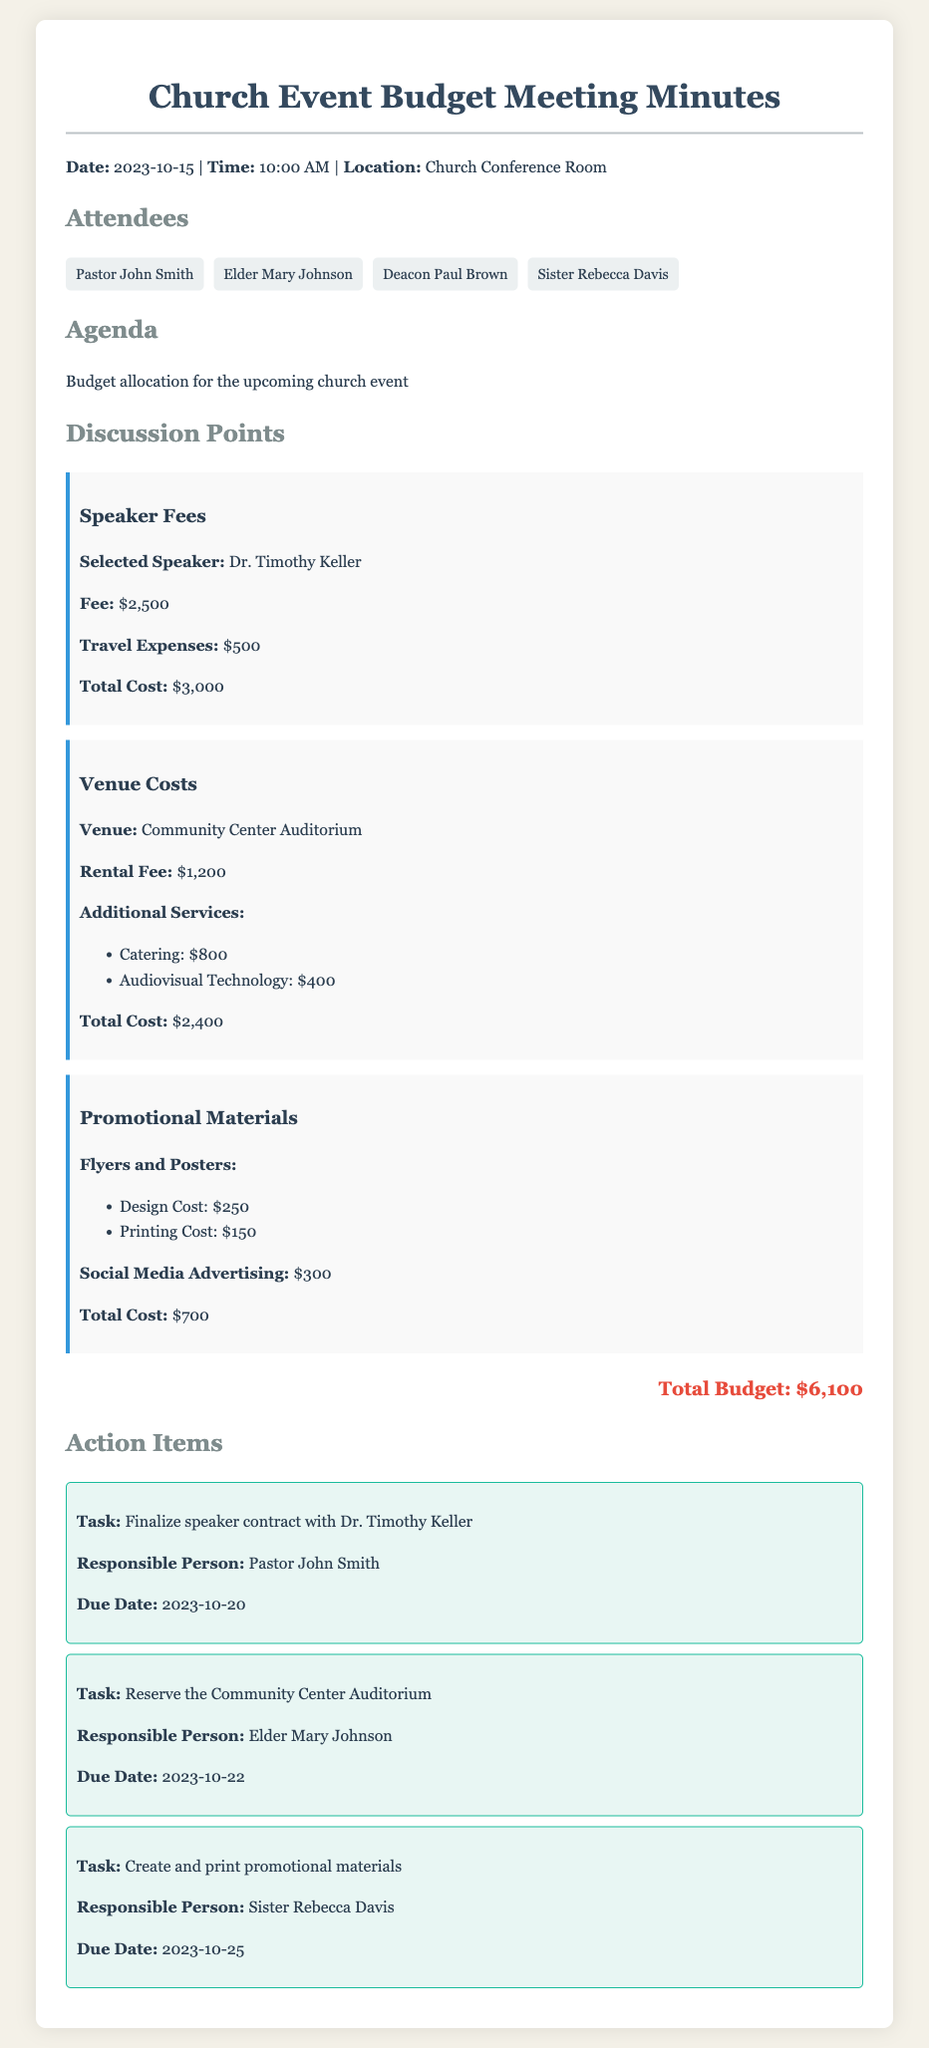What is the date of the meeting? The date of the meeting is mentioned at the beginning of the document.
Answer: 2023-10-15 Who is the selected speaker for the event? The selected speaker is listed under the discussion points section.
Answer: Dr. Timothy Keller What is the total cost for speaker fees? The total cost for speaker fees is calculated in the discussion points section.
Answer: $3,000 What is the rental fee for the venue? The rental fee is highlighted in the venue costs section.
Answer: $1,200 How much is allocated for promotional materials? The total cost for promotional materials is discussed in the corresponding section.
Answer: $700 What is the due date for finalizing the speaker contract? The due date is provided in the action items section.
Answer: 2023-10-20 How many attendees are listed in the document? The number of attendees can be counted from the attendees section.
Answer: 4 What is the total budget for the church event? The total budget is summarized at the end of the discussion points.
Answer: $6,100 Who is responsible for creating and printing promotional materials? The responsible person's name is specified in the action items.
Answer: Sister Rebecca Davis 